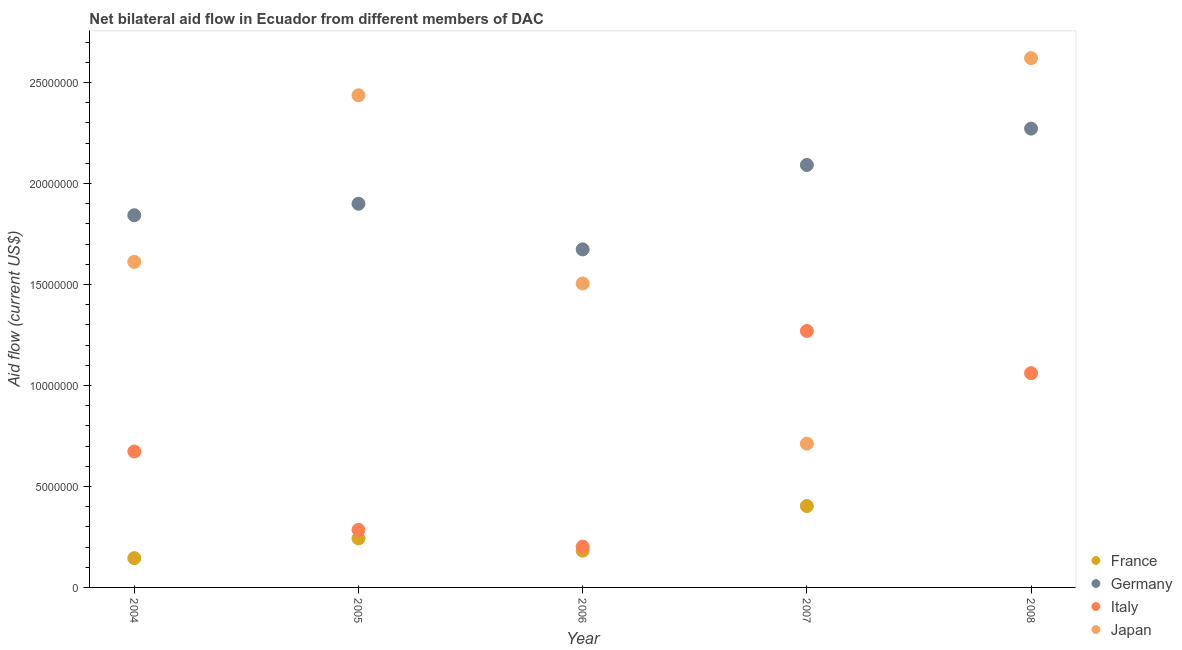How many different coloured dotlines are there?
Make the answer very short. 4. What is the amount of aid given by germany in 2004?
Provide a short and direct response. 1.84e+07. Across all years, what is the maximum amount of aid given by france?
Your answer should be compact. 4.03e+06. Across all years, what is the minimum amount of aid given by japan?
Your answer should be compact. 7.12e+06. What is the total amount of aid given by germany in the graph?
Ensure brevity in your answer.  9.78e+07. What is the difference between the amount of aid given by japan in 2006 and that in 2007?
Offer a very short reply. 7.93e+06. What is the difference between the amount of aid given by france in 2007 and the amount of aid given by germany in 2008?
Offer a terse response. -1.87e+07. What is the average amount of aid given by germany per year?
Provide a succinct answer. 1.96e+07. In the year 2004, what is the difference between the amount of aid given by france and amount of aid given by italy?
Provide a short and direct response. -5.28e+06. In how many years, is the amount of aid given by france greater than 16000000 US$?
Ensure brevity in your answer.  0. What is the ratio of the amount of aid given by japan in 2005 to that in 2008?
Your answer should be very brief. 0.93. Is the difference between the amount of aid given by france in 2004 and 2007 greater than the difference between the amount of aid given by germany in 2004 and 2007?
Your response must be concise. No. What is the difference between the highest and the second highest amount of aid given by france?
Provide a succinct answer. 1.60e+06. What is the difference between the highest and the lowest amount of aid given by france?
Keep it short and to the point. 4.03e+06. In how many years, is the amount of aid given by japan greater than the average amount of aid given by japan taken over all years?
Your answer should be very brief. 2. Is the sum of the amount of aid given by germany in 2005 and 2006 greater than the maximum amount of aid given by japan across all years?
Offer a very short reply. Yes. Does the amount of aid given by france monotonically increase over the years?
Your answer should be very brief. No. How many dotlines are there?
Provide a short and direct response. 4. What is the difference between two consecutive major ticks on the Y-axis?
Give a very brief answer. 5.00e+06. Are the values on the major ticks of Y-axis written in scientific E-notation?
Give a very brief answer. No. Does the graph contain any zero values?
Keep it short and to the point. Yes. Where does the legend appear in the graph?
Provide a succinct answer. Bottom right. How are the legend labels stacked?
Your answer should be very brief. Vertical. What is the title of the graph?
Keep it short and to the point. Net bilateral aid flow in Ecuador from different members of DAC. Does "Regional development banks" appear as one of the legend labels in the graph?
Make the answer very short. No. What is the Aid flow (current US$) of France in 2004?
Offer a terse response. 1.45e+06. What is the Aid flow (current US$) of Germany in 2004?
Offer a terse response. 1.84e+07. What is the Aid flow (current US$) of Italy in 2004?
Keep it short and to the point. 6.73e+06. What is the Aid flow (current US$) of Japan in 2004?
Ensure brevity in your answer.  1.61e+07. What is the Aid flow (current US$) of France in 2005?
Ensure brevity in your answer.  2.43e+06. What is the Aid flow (current US$) of Germany in 2005?
Offer a terse response. 1.90e+07. What is the Aid flow (current US$) in Italy in 2005?
Your answer should be very brief. 2.85e+06. What is the Aid flow (current US$) in Japan in 2005?
Keep it short and to the point. 2.44e+07. What is the Aid flow (current US$) of France in 2006?
Make the answer very short. 1.82e+06. What is the Aid flow (current US$) in Germany in 2006?
Ensure brevity in your answer.  1.67e+07. What is the Aid flow (current US$) of Italy in 2006?
Offer a very short reply. 2.02e+06. What is the Aid flow (current US$) of Japan in 2006?
Your answer should be compact. 1.50e+07. What is the Aid flow (current US$) of France in 2007?
Your response must be concise. 4.03e+06. What is the Aid flow (current US$) of Germany in 2007?
Make the answer very short. 2.09e+07. What is the Aid flow (current US$) of Italy in 2007?
Your answer should be very brief. 1.27e+07. What is the Aid flow (current US$) in Japan in 2007?
Your answer should be very brief. 7.12e+06. What is the Aid flow (current US$) in France in 2008?
Your answer should be compact. 0. What is the Aid flow (current US$) of Germany in 2008?
Give a very brief answer. 2.27e+07. What is the Aid flow (current US$) of Italy in 2008?
Offer a very short reply. 1.06e+07. What is the Aid flow (current US$) in Japan in 2008?
Your answer should be compact. 2.62e+07. Across all years, what is the maximum Aid flow (current US$) in France?
Offer a terse response. 4.03e+06. Across all years, what is the maximum Aid flow (current US$) in Germany?
Provide a succinct answer. 2.27e+07. Across all years, what is the maximum Aid flow (current US$) in Italy?
Offer a very short reply. 1.27e+07. Across all years, what is the maximum Aid flow (current US$) of Japan?
Your response must be concise. 2.62e+07. Across all years, what is the minimum Aid flow (current US$) of France?
Your answer should be compact. 0. Across all years, what is the minimum Aid flow (current US$) in Germany?
Your answer should be very brief. 1.67e+07. Across all years, what is the minimum Aid flow (current US$) in Italy?
Offer a very short reply. 2.02e+06. Across all years, what is the minimum Aid flow (current US$) of Japan?
Your response must be concise. 7.12e+06. What is the total Aid flow (current US$) in France in the graph?
Make the answer very short. 9.73e+06. What is the total Aid flow (current US$) in Germany in the graph?
Keep it short and to the point. 9.78e+07. What is the total Aid flow (current US$) in Italy in the graph?
Offer a very short reply. 3.49e+07. What is the total Aid flow (current US$) in Japan in the graph?
Make the answer very short. 8.89e+07. What is the difference between the Aid flow (current US$) in France in 2004 and that in 2005?
Your answer should be very brief. -9.80e+05. What is the difference between the Aid flow (current US$) in Germany in 2004 and that in 2005?
Ensure brevity in your answer.  -5.70e+05. What is the difference between the Aid flow (current US$) in Italy in 2004 and that in 2005?
Give a very brief answer. 3.88e+06. What is the difference between the Aid flow (current US$) in Japan in 2004 and that in 2005?
Offer a very short reply. -8.25e+06. What is the difference between the Aid flow (current US$) in France in 2004 and that in 2006?
Your response must be concise. -3.70e+05. What is the difference between the Aid flow (current US$) of Germany in 2004 and that in 2006?
Your answer should be very brief. 1.69e+06. What is the difference between the Aid flow (current US$) of Italy in 2004 and that in 2006?
Keep it short and to the point. 4.71e+06. What is the difference between the Aid flow (current US$) in Japan in 2004 and that in 2006?
Your answer should be very brief. 1.07e+06. What is the difference between the Aid flow (current US$) of France in 2004 and that in 2007?
Your answer should be very brief. -2.58e+06. What is the difference between the Aid flow (current US$) of Germany in 2004 and that in 2007?
Provide a succinct answer. -2.49e+06. What is the difference between the Aid flow (current US$) in Italy in 2004 and that in 2007?
Offer a terse response. -5.97e+06. What is the difference between the Aid flow (current US$) of Japan in 2004 and that in 2007?
Give a very brief answer. 9.00e+06. What is the difference between the Aid flow (current US$) in Germany in 2004 and that in 2008?
Provide a succinct answer. -4.29e+06. What is the difference between the Aid flow (current US$) in Italy in 2004 and that in 2008?
Keep it short and to the point. -3.88e+06. What is the difference between the Aid flow (current US$) of Japan in 2004 and that in 2008?
Your response must be concise. -1.01e+07. What is the difference between the Aid flow (current US$) in France in 2005 and that in 2006?
Your answer should be very brief. 6.10e+05. What is the difference between the Aid flow (current US$) in Germany in 2005 and that in 2006?
Offer a terse response. 2.26e+06. What is the difference between the Aid flow (current US$) in Italy in 2005 and that in 2006?
Keep it short and to the point. 8.30e+05. What is the difference between the Aid flow (current US$) in Japan in 2005 and that in 2006?
Provide a succinct answer. 9.32e+06. What is the difference between the Aid flow (current US$) in France in 2005 and that in 2007?
Ensure brevity in your answer.  -1.60e+06. What is the difference between the Aid flow (current US$) of Germany in 2005 and that in 2007?
Your answer should be compact. -1.92e+06. What is the difference between the Aid flow (current US$) of Italy in 2005 and that in 2007?
Offer a very short reply. -9.85e+06. What is the difference between the Aid flow (current US$) of Japan in 2005 and that in 2007?
Give a very brief answer. 1.72e+07. What is the difference between the Aid flow (current US$) of Germany in 2005 and that in 2008?
Your answer should be compact. -3.72e+06. What is the difference between the Aid flow (current US$) in Italy in 2005 and that in 2008?
Keep it short and to the point. -7.76e+06. What is the difference between the Aid flow (current US$) of Japan in 2005 and that in 2008?
Offer a very short reply. -1.84e+06. What is the difference between the Aid flow (current US$) of France in 2006 and that in 2007?
Ensure brevity in your answer.  -2.21e+06. What is the difference between the Aid flow (current US$) of Germany in 2006 and that in 2007?
Your response must be concise. -4.18e+06. What is the difference between the Aid flow (current US$) of Italy in 2006 and that in 2007?
Your answer should be very brief. -1.07e+07. What is the difference between the Aid flow (current US$) of Japan in 2006 and that in 2007?
Ensure brevity in your answer.  7.93e+06. What is the difference between the Aid flow (current US$) of Germany in 2006 and that in 2008?
Keep it short and to the point. -5.98e+06. What is the difference between the Aid flow (current US$) in Italy in 2006 and that in 2008?
Provide a succinct answer. -8.59e+06. What is the difference between the Aid flow (current US$) in Japan in 2006 and that in 2008?
Provide a short and direct response. -1.12e+07. What is the difference between the Aid flow (current US$) of Germany in 2007 and that in 2008?
Keep it short and to the point. -1.80e+06. What is the difference between the Aid flow (current US$) of Italy in 2007 and that in 2008?
Keep it short and to the point. 2.09e+06. What is the difference between the Aid flow (current US$) of Japan in 2007 and that in 2008?
Make the answer very short. -1.91e+07. What is the difference between the Aid flow (current US$) of France in 2004 and the Aid flow (current US$) of Germany in 2005?
Give a very brief answer. -1.76e+07. What is the difference between the Aid flow (current US$) of France in 2004 and the Aid flow (current US$) of Italy in 2005?
Offer a very short reply. -1.40e+06. What is the difference between the Aid flow (current US$) in France in 2004 and the Aid flow (current US$) in Japan in 2005?
Provide a succinct answer. -2.29e+07. What is the difference between the Aid flow (current US$) of Germany in 2004 and the Aid flow (current US$) of Italy in 2005?
Provide a succinct answer. 1.56e+07. What is the difference between the Aid flow (current US$) of Germany in 2004 and the Aid flow (current US$) of Japan in 2005?
Your answer should be very brief. -5.94e+06. What is the difference between the Aid flow (current US$) in Italy in 2004 and the Aid flow (current US$) in Japan in 2005?
Keep it short and to the point. -1.76e+07. What is the difference between the Aid flow (current US$) in France in 2004 and the Aid flow (current US$) in Germany in 2006?
Your answer should be very brief. -1.53e+07. What is the difference between the Aid flow (current US$) in France in 2004 and the Aid flow (current US$) in Italy in 2006?
Provide a short and direct response. -5.70e+05. What is the difference between the Aid flow (current US$) of France in 2004 and the Aid flow (current US$) of Japan in 2006?
Your answer should be very brief. -1.36e+07. What is the difference between the Aid flow (current US$) of Germany in 2004 and the Aid flow (current US$) of Italy in 2006?
Keep it short and to the point. 1.64e+07. What is the difference between the Aid flow (current US$) of Germany in 2004 and the Aid flow (current US$) of Japan in 2006?
Keep it short and to the point. 3.38e+06. What is the difference between the Aid flow (current US$) of Italy in 2004 and the Aid flow (current US$) of Japan in 2006?
Ensure brevity in your answer.  -8.32e+06. What is the difference between the Aid flow (current US$) in France in 2004 and the Aid flow (current US$) in Germany in 2007?
Your answer should be very brief. -1.95e+07. What is the difference between the Aid flow (current US$) of France in 2004 and the Aid flow (current US$) of Italy in 2007?
Provide a short and direct response. -1.12e+07. What is the difference between the Aid flow (current US$) in France in 2004 and the Aid flow (current US$) in Japan in 2007?
Provide a succinct answer. -5.67e+06. What is the difference between the Aid flow (current US$) of Germany in 2004 and the Aid flow (current US$) of Italy in 2007?
Offer a very short reply. 5.73e+06. What is the difference between the Aid flow (current US$) of Germany in 2004 and the Aid flow (current US$) of Japan in 2007?
Make the answer very short. 1.13e+07. What is the difference between the Aid flow (current US$) of Italy in 2004 and the Aid flow (current US$) of Japan in 2007?
Offer a terse response. -3.90e+05. What is the difference between the Aid flow (current US$) in France in 2004 and the Aid flow (current US$) in Germany in 2008?
Your response must be concise. -2.13e+07. What is the difference between the Aid flow (current US$) in France in 2004 and the Aid flow (current US$) in Italy in 2008?
Your answer should be very brief. -9.16e+06. What is the difference between the Aid flow (current US$) in France in 2004 and the Aid flow (current US$) in Japan in 2008?
Provide a short and direct response. -2.48e+07. What is the difference between the Aid flow (current US$) in Germany in 2004 and the Aid flow (current US$) in Italy in 2008?
Your answer should be compact. 7.82e+06. What is the difference between the Aid flow (current US$) of Germany in 2004 and the Aid flow (current US$) of Japan in 2008?
Keep it short and to the point. -7.78e+06. What is the difference between the Aid flow (current US$) of Italy in 2004 and the Aid flow (current US$) of Japan in 2008?
Your response must be concise. -1.95e+07. What is the difference between the Aid flow (current US$) of France in 2005 and the Aid flow (current US$) of Germany in 2006?
Ensure brevity in your answer.  -1.43e+07. What is the difference between the Aid flow (current US$) of France in 2005 and the Aid flow (current US$) of Italy in 2006?
Provide a succinct answer. 4.10e+05. What is the difference between the Aid flow (current US$) of France in 2005 and the Aid flow (current US$) of Japan in 2006?
Keep it short and to the point. -1.26e+07. What is the difference between the Aid flow (current US$) in Germany in 2005 and the Aid flow (current US$) in Italy in 2006?
Your response must be concise. 1.70e+07. What is the difference between the Aid flow (current US$) of Germany in 2005 and the Aid flow (current US$) of Japan in 2006?
Offer a very short reply. 3.95e+06. What is the difference between the Aid flow (current US$) in Italy in 2005 and the Aid flow (current US$) in Japan in 2006?
Make the answer very short. -1.22e+07. What is the difference between the Aid flow (current US$) of France in 2005 and the Aid flow (current US$) of Germany in 2007?
Offer a very short reply. -1.85e+07. What is the difference between the Aid flow (current US$) of France in 2005 and the Aid flow (current US$) of Italy in 2007?
Give a very brief answer. -1.03e+07. What is the difference between the Aid flow (current US$) in France in 2005 and the Aid flow (current US$) in Japan in 2007?
Keep it short and to the point. -4.69e+06. What is the difference between the Aid flow (current US$) in Germany in 2005 and the Aid flow (current US$) in Italy in 2007?
Give a very brief answer. 6.30e+06. What is the difference between the Aid flow (current US$) in Germany in 2005 and the Aid flow (current US$) in Japan in 2007?
Ensure brevity in your answer.  1.19e+07. What is the difference between the Aid flow (current US$) of Italy in 2005 and the Aid flow (current US$) of Japan in 2007?
Offer a very short reply. -4.27e+06. What is the difference between the Aid flow (current US$) in France in 2005 and the Aid flow (current US$) in Germany in 2008?
Give a very brief answer. -2.03e+07. What is the difference between the Aid flow (current US$) of France in 2005 and the Aid flow (current US$) of Italy in 2008?
Offer a terse response. -8.18e+06. What is the difference between the Aid flow (current US$) in France in 2005 and the Aid flow (current US$) in Japan in 2008?
Offer a terse response. -2.38e+07. What is the difference between the Aid flow (current US$) in Germany in 2005 and the Aid flow (current US$) in Italy in 2008?
Your response must be concise. 8.39e+06. What is the difference between the Aid flow (current US$) in Germany in 2005 and the Aid flow (current US$) in Japan in 2008?
Provide a short and direct response. -7.21e+06. What is the difference between the Aid flow (current US$) in Italy in 2005 and the Aid flow (current US$) in Japan in 2008?
Offer a terse response. -2.34e+07. What is the difference between the Aid flow (current US$) of France in 2006 and the Aid flow (current US$) of Germany in 2007?
Ensure brevity in your answer.  -1.91e+07. What is the difference between the Aid flow (current US$) in France in 2006 and the Aid flow (current US$) in Italy in 2007?
Provide a succinct answer. -1.09e+07. What is the difference between the Aid flow (current US$) of France in 2006 and the Aid flow (current US$) of Japan in 2007?
Ensure brevity in your answer.  -5.30e+06. What is the difference between the Aid flow (current US$) in Germany in 2006 and the Aid flow (current US$) in Italy in 2007?
Provide a short and direct response. 4.04e+06. What is the difference between the Aid flow (current US$) of Germany in 2006 and the Aid flow (current US$) of Japan in 2007?
Offer a terse response. 9.62e+06. What is the difference between the Aid flow (current US$) of Italy in 2006 and the Aid flow (current US$) of Japan in 2007?
Ensure brevity in your answer.  -5.10e+06. What is the difference between the Aid flow (current US$) in France in 2006 and the Aid flow (current US$) in Germany in 2008?
Offer a very short reply. -2.09e+07. What is the difference between the Aid flow (current US$) of France in 2006 and the Aid flow (current US$) of Italy in 2008?
Ensure brevity in your answer.  -8.79e+06. What is the difference between the Aid flow (current US$) of France in 2006 and the Aid flow (current US$) of Japan in 2008?
Offer a very short reply. -2.44e+07. What is the difference between the Aid flow (current US$) in Germany in 2006 and the Aid flow (current US$) in Italy in 2008?
Your response must be concise. 6.13e+06. What is the difference between the Aid flow (current US$) of Germany in 2006 and the Aid flow (current US$) of Japan in 2008?
Offer a terse response. -9.47e+06. What is the difference between the Aid flow (current US$) of Italy in 2006 and the Aid flow (current US$) of Japan in 2008?
Provide a short and direct response. -2.42e+07. What is the difference between the Aid flow (current US$) in France in 2007 and the Aid flow (current US$) in Germany in 2008?
Your response must be concise. -1.87e+07. What is the difference between the Aid flow (current US$) in France in 2007 and the Aid flow (current US$) in Italy in 2008?
Your response must be concise. -6.58e+06. What is the difference between the Aid flow (current US$) in France in 2007 and the Aid flow (current US$) in Japan in 2008?
Keep it short and to the point. -2.22e+07. What is the difference between the Aid flow (current US$) in Germany in 2007 and the Aid flow (current US$) in Italy in 2008?
Offer a terse response. 1.03e+07. What is the difference between the Aid flow (current US$) in Germany in 2007 and the Aid flow (current US$) in Japan in 2008?
Give a very brief answer. -5.29e+06. What is the difference between the Aid flow (current US$) in Italy in 2007 and the Aid flow (current US$) in Japan in 2008?
Your answer should be compact. -1.35e+07. What is the average Aid flow (current US$) of France per year?
Offer a very short reply. 1.95e+06. What is the average Aid flow (current US$) in Germany per year?
Make the answer very short. 1.96e+07. What is the average Aid flow (current US$) in Italy per year?
Give a very brief answer. 6.98e+06. What is the average Aid flow (current US$) of Japan per year?
Provide a short and direct response. 1.78e+07. In the year 2004, what is the difference between the Aid flow (current US$) of France and Aid flow (current US$) of Germany?
Give a very brief answer. -1.70e+07. In the year 2004, what is the difference between the Aid flow (current US$) in France and Aid flow (current US$) in Italy?
Make the answer very short. -5.28e+06. In the year 2004, what is the difference between the Aid flow (current US$) of France and Aid flow (current US$) of Japan?
Provide a short and direct response. -1.47e+07. In the year 2004, what is the difference between the Aid flow (current US$) in Germany and Aid flow (current US$) in Italy?
Offer a terse response. 1.17e+07. In the year 2004, what is the difference between the Aid flow (current US$) in Germany and Aid flow (current US$) in Japan?
Keep it short and to the point. 2.31e+06. In the year 2004, what is the difference between the Aid flow (current US$) of Italy and Aid flow (current US$) of Japan?
Your answer should be very brief. -9.39e+06. In the year 2005, what is the difference between the Aid flow (current US$) of France and Aid flow (current US$) of Germany?
Give a very brief answer. -1.66e+07. In the year 2005, what is the difference between the Aid flow (current US$) of France and Aid flow (current US$) of Italy?
Give a very brief answer. -4.20e+05. In the year 2005, what is the difference between the Aid flow (current US$) of France and Aid flow (current US$) of Japan?
Offer a terse response. -2.19e+07. In the year 2005, what is the difference between the Aid flow (current US$) in Germany and Aid flow (current US$) in Italy?
Your answer should be compact. 1.62e+07. In the year 2005, what is the difference between the Aid flow (current US$) in Germany and Aid flow (current US$) in Japan?
Make the answer very short. -5.37e+06. In the year 2005, what is the difference between the Aid flow (current US$) of Italy and Aid flow (current US$) of Japan?
Keep it short and to the point. -2.15e+07. In the year 2006, what is the difference between the Aid flow (current US$) in France and Aid flow (current US$) in Germany?
Give a very brief answer. -1.49e+07. In the year 2006, what is the difference between the Aid flow (current US$) in France and Aid flow (current US$) in Japan?
Make the answer very short. -1.32e+07. In the year 2006, what is the difference between the Aid flow (current US$) of Germany and Aid flow (current US$) of Italy?
Ensure brevity in your answer.  1.47e+07. In the year 2006, what is the difference between the Aid flow (current US$) in Germany and Aid flow (current US$) in Japan?
Ensure brevity in your answer.  1.69e+06. In the year 2006, what is the difference between the Aid flow (current US$) of Italy and Aid flow (current US$) of Japan?
Make the answer very short. -1.30e+07. In the year 2007, what is the difference between the Aid flow (current US$) of France and Aid flow (current US$) of Germany?
Your response must be concise. -1.69e+07. In the year 2007, what is the difference between the Aid flow (current US$) of France and Aid flow (current US$) of Italy?
Your answer should be compact. -8.67e+06. In the year 2007, what is the difference between the Aid flow (current US$) of France and Aid flow (current US$) of Japan?
Offer a terse response. -3.09e+06. In the year 2007, what is the difference between the Aid flow (current US$) of Germany and Aid flow (current US$) of Italy?
Provide a succinct answer. 8.22e+06. In the year 2007, what is the difference between the Aid flow (current US$) in Germany and Aid flow (current US$) in Japan?
Your answer should be very brief. 1.38e+07. In the year 2007, what is the difference between the Aid flow (current US$) in Italy and Aid flow (current US$) in Japan?
Your answer should be compact. 5.58e+06. In the year 2008, what is the difference between the Aid flow (current US$) of Germany and Aid flow (current US$) of Italy?
Give a very brief answer. 1.21e+07. In the year 2008, what is the difference between the Aid flow (current US$) in Germany and Aid flow (current US$) in Japan?
Provide a short and direct response. -3.49e+06. In the year 2008, what is the difference between the Aid flow (current US$) of Italy and Aid flow (current US$) of Japan?
Give a very brief answer. -1.56e+07. What is the ratio of the Aid flow (current US$) of France in 2004 to that in 2005?
Provide a succinct answer. 0.6. What is the ratio of the Aid flow (current US$) of Italy in 2004 to that in 2005?
Your answer should be very brief. 2.36. What is the ratio of the Aid flow (current US$) of Japan in 2004 to that in 2005?
Provide a succinct answer. 0.66. What is the ratio of the Aid flow (current US$) of France in 2004 to that in 2006?
Make the answer very short. 0.8. What is the ratio of the Aid flow (current US$) of Germany in 2004 to that in 2006?
Your answer should be compact. 1.1. What is the ratio of the Aid flow (current US$) of Italy in 2004 to that in 2006?
Ensure brevity in your answer.  3.33. What is the ratio of the Aid flow (current US$) of Japan in 2004 to that in 2006?
Offer a very short reply. 1.07. What is the ratio of the Aid flow (current US$) in France in 2004 to that in 2007?
Your answer should be very brief. 0.36. What is the ratio of the Aid flow (current US$) of Germany in 2004 to that in 2007?
Keep it short and to the point. 0.88. What is the ratio of the Aid flow (current US$) of Italy in 2004 to that in 2007?
Your answer should be very brief. 0.53. What is the ratio of the Aid flow (current US$) of Japan in 2004 to that in 2007?
Ensure brevity in your answer.  2.26. What is the ratio of the Aid flow (current US$) of Germany in 2004 to that in 2008?
Your answer should be very brief. 0.81. What is the ratio of the Aid flow (current US$) in Italy in 2004 to that in 2008?
Offer a terse response. 0.63. What is the ratio of the Aid flow (current US$) in Japan in 2004 to that in 2008?
Provide a short and direct response. 0.61. What is the ratio of the Aid flow (current US$) of France in 2005 to that in 2006?
Ensure brevity in your answer.  1.34. What is the ratio of the Aid flow (current US$) in Germany in 2005 to that in 2006?
Offer a terse response. 1.14. What is the ratio of the Aid flow (current US$) of Italy in 2005 to that in 2006?
Keep it short and to the point. 1.41. What is the ratio of the Aid flow (current US$) of Japan in 2005 to that in 2006?
Make the answer very short. 1.62. What is the ratio of the Aid flow (current US$) in France in 2005 to that in 2007?
Offer a very short reply. 0.6. What is the ratio of the Aid flow (current US$) in Germany in 2005 to that in 2007?
Give a very brief answer. 0.91. What is the ratio of the Aid flow (current US$) in Italy in 2005 to that in 2007?
Keep it short and to the point. 0.22. What is the ratio of the Aid flow (current US$) of Japan in 2005 to that in 2007?
Offer a terse response. 3.42. What is the ratio of the Aid flow (current US$) of Germany in 2005 to that in 2008?
Ensure brevity in your answer.  0.84. What is the ratio of the Aid flow (current US$) in Italy in 2005 to that in 2008?
Make the answer very short. 0.27. What is the ratio of the Aid flow (current US$) of Japan in 2005 to that in 2008?
Your answer should be compact. 0.93. What is the ratio of the Aid flow (current US$) in France in 2006 to that in 2007?
Offer a terse response. 0.45. What is the ratio of the Aid flow (current US$) of Germany in 2006 to that in 2007?
Make the answer very short. 0.8. What is the ratio of the Aid flow (current US$) of Italy in 2006 to that in 2007?
Ensure brevity in your answer.  0.16. What is the ratio of the Aid flow (current US$) of Japan in 2006 to that in 2007?
Your response must be concise. 2.11. What is the ratio of the Aid flow (current US$) in Germany in 2006 to that in 2008?
Provide a short and direct response. 0.74. What is the ratio of the Aid flow (current US$) of Italy in 2006 to that in 2008?
Offer a very short reply. 0.19. What is the ratio of the Aid flow (current US$) of Japan in 2006 to that in 2008?
Provide a succinct answer. 0.57. What is the ratio of the Aid flow (current US$) in Germany in 2007 to that in 2008?
Ensure brevity in your answer.  0.92. What is the ratio of the Aid flow (current US$) in Italy in 2007 to that in 2008?
Ensure brevity in your answer.  1.2. What is the ratio of the Aid flow (current US$) in Japan in 2007 to that in 2008?
Your response must be concise. 0.27. What is the difference between the highest and the second highest Aid flow (current US$) in France?
Keep it short and to the point. 1.60e+06. What is the difference between the highest and the second highest Aid flow (current US$) of Germany?
Provide a short and direct response. 1.80e+06. What is the difference between the highest and the second highest Aid flow (current US$) in Italy?
Give a very brief answer. 2.09e+06. What is the difference between the highest and the second highest Aid flow (current US$) in Japan?
Provide a short and direct response. 1.84e+06. What is the difference between the highest and the lowest Aid flow (current US$) of France?
Offer a very short reply. 4.03e+06. What is the difference between the highest and the lowest Aid flow (current US$) of Germany?
Offer a very short reply. 5.98e+06. What is the difference between the highest and the lowest Aid flow (current US$) of Italy?
Offer a terse response. 1.07e+07. What is the difference between the highest and the lowest Aid flow (current US$) in Japan?
Your answer should be very brief. 1.91e+07. 